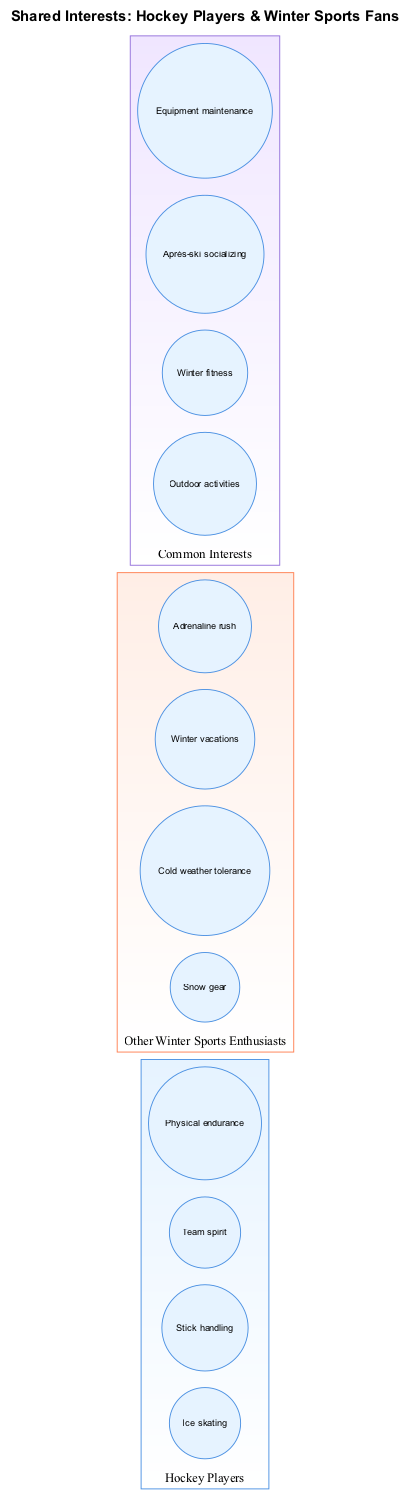What elements are included under "Hockey Players"? The diagram lists four specific elements for the "Hockey Players" set: Ice skating, Stick handling, Team spirit, and Physical endurance. This information is found specifically in the node labeled "Hockey Players."
Answer: Ice skating, Stick handling, Team spirit, Physical endurance How many elements are there in "Other Winter Sports Enthusiasts"? There are four elements listed under the "Other Winter Sports Enthusiasts" set: Snow gear, Cold weather tolerance, Winter vacations, and Adrenaline rush. Thus, the count of elements is derived by counting these items.
Answer: 4 What is one common interest shared by both sets? The intersection of the two sets includes four common interests. One of those is "Outdoor activities," which can be found in the section labeled "Common Interests."
Answer: Outdoor activities What does the "Common Interests" label represent in the diagram? The "Common Interests" label in the diagram indicates the overlapping area between the two sets, reflecting shared interests, specifically listing items like Outdoor activities, Winter fitness, and others.
Answer: Overlapping interests Which interest relates to physical activity in winter? Winter fitness is included in the intersection (Common Interests) which ties to physical activity during the winter season, showcasing its relevance to both hockey players and winter sports enthusiasts.
Answer: Winter fitness Is "Cold weather tolerance" an interest of hockey players? "Cold weather tolerance" is exclusively listed under "Other Winter Sports Enthusiasts" indicating it is not directly an interest of hockey players, but a characteristic relevant to winter sports overall.
Answer: No What color represents the "Hockey Players" set in the diagram? The "Hockey Players" set is represented using a blue shade, specifically noted by its color attributes in the diagram setup (light blue for fill).
Answer: Blue How does the diagram illustrate the relationship between hockey players and winter sports fans? The diagram uses a Venn structure to show two separate sets with an overlapping area. The overlapping section contains interests that connect both "Hockey Players" and "Other Winter Sports Enthusiasts," highlighting their shared activities.
Answer: Venn structure with overlapping interests 